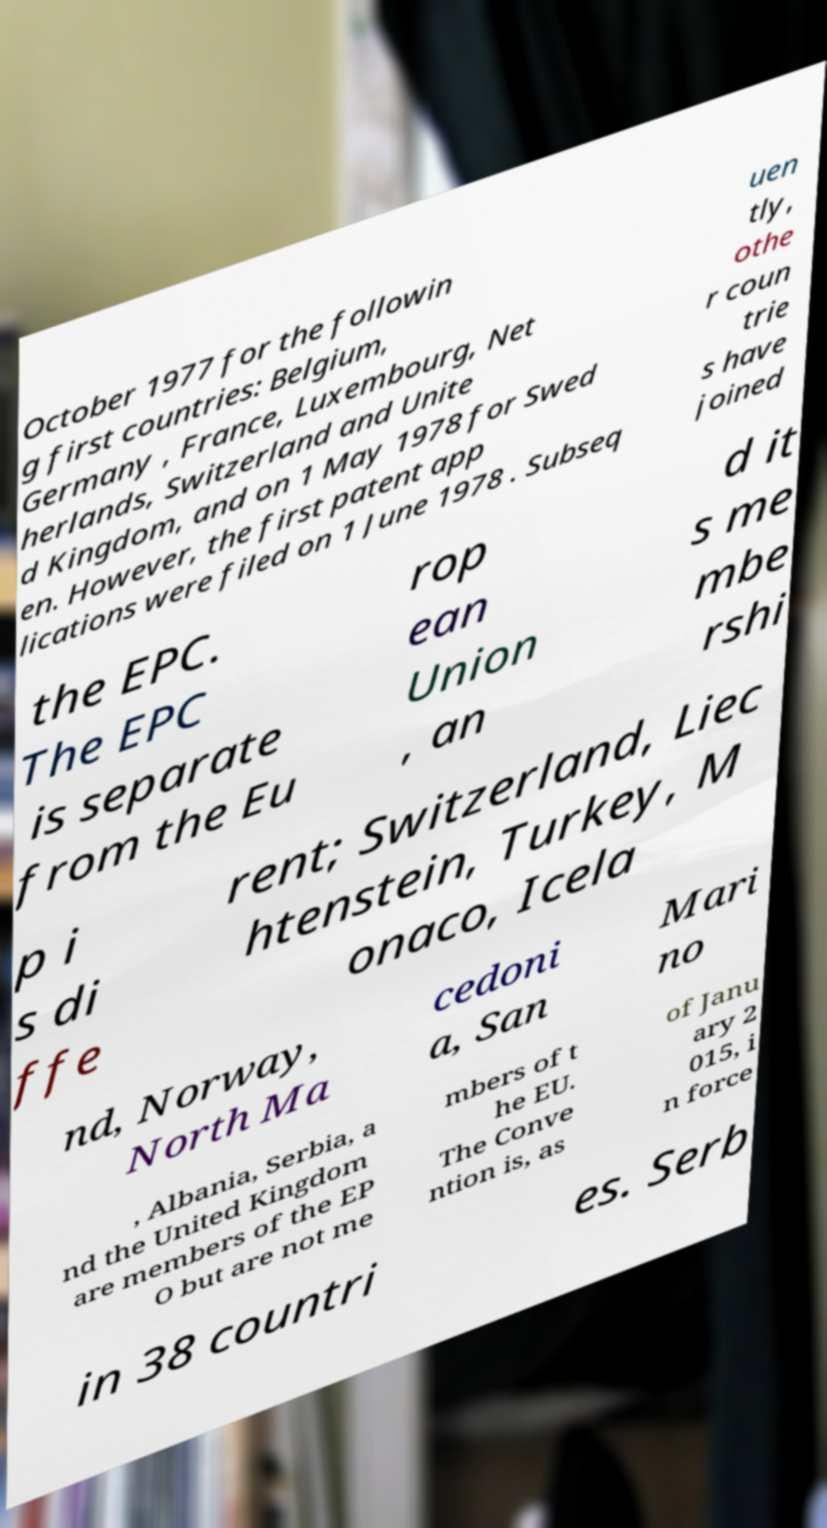Can you read and provide the text displayed in the image?This photo seems to have some interesting text. Can you extract and type it out for me? October 1977 for the followin g first countries: Belgium, Germany , France, Luxembourg, Net herlands, Switzerland and Unite d Kingdom, and on 1 May 1978 for Swed en. However, the first patent app lications were filed on 1 June 1978 . Subseq uen tly, othe r coun trie s have joined the EPC. The EPC is separate from the Eu rop ean Union , an d it s me mbe rshi p i s di ffe rent; Switzerland, Liec htenstein, Turkey, M onaco, Icela nd, Norway, North Ma cedoni a, San Mari no , Albania, Serbia, a nd the United Kingdom are members of the EP O but are not me mbers of t he EU. The Conve ntion is, as of Janu ary 2 015, i n force in 38 countri es. Serb 